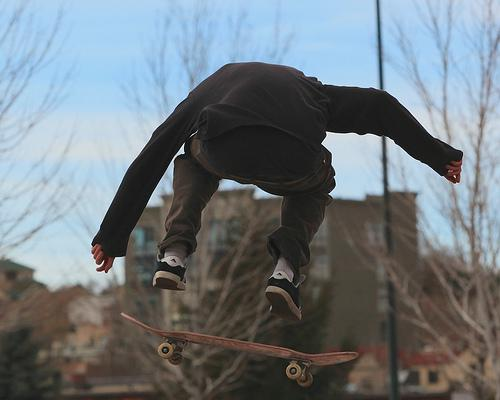Question: where is the skateboarder?
Choices:
A. At a park.
B. At a neighborhood.
C. At a plaza.
D. On a street.
Answer with the letter. Answer: A Question: how many skateboarders are pictured?
Choices:
A. Three.
B. One.
C. Five.
D. Six.
Answer with the letter. Answer: B Question: what is in the background?
Choices:
A. Mountains.
B. Hills.
C. Buildings and trees.
D. Forrest.
Answer with the letter. Answer: C Question: what color are the skateboarder's shoes?
Choices:
A. Black and blue.
B. Black and white.
C. Blue and white.
D. Red and white.
Answer with the letter. Answer: B Question: who is doing the jump trick?
Choices:
A. The skateboarder.
B. The rollerblader.
C. The biker.
D. The man on the scooter.
Answer with the letter. Answer: A 